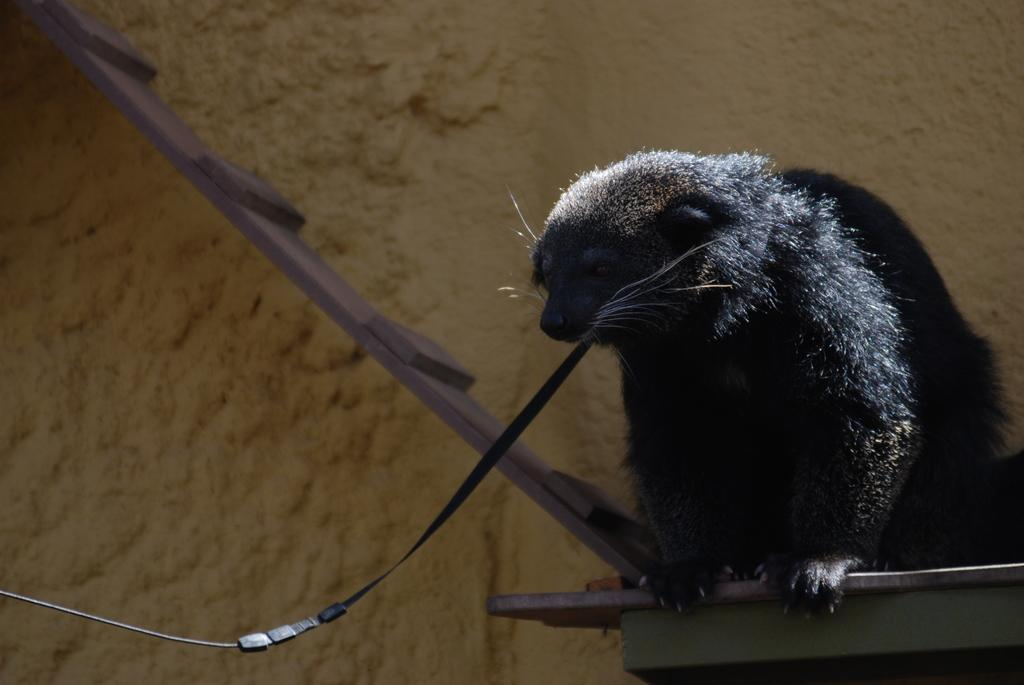What type of animal can be seen in the image? There is an animal in the image, but its specific type is not mentioned in the facts. What is the animal doing in the image? The animal is holding a wire with its mouth. What can be seen in the background of the image? There is a wall and a wooden plank in the background of the image. What type of horn can be seen on the animal in the image? There is no mention of a horn on the animal in the image. Can you read the note that the animal is holding in the image? There is no note present in the image; the animal is holding a wire with its mouth. 